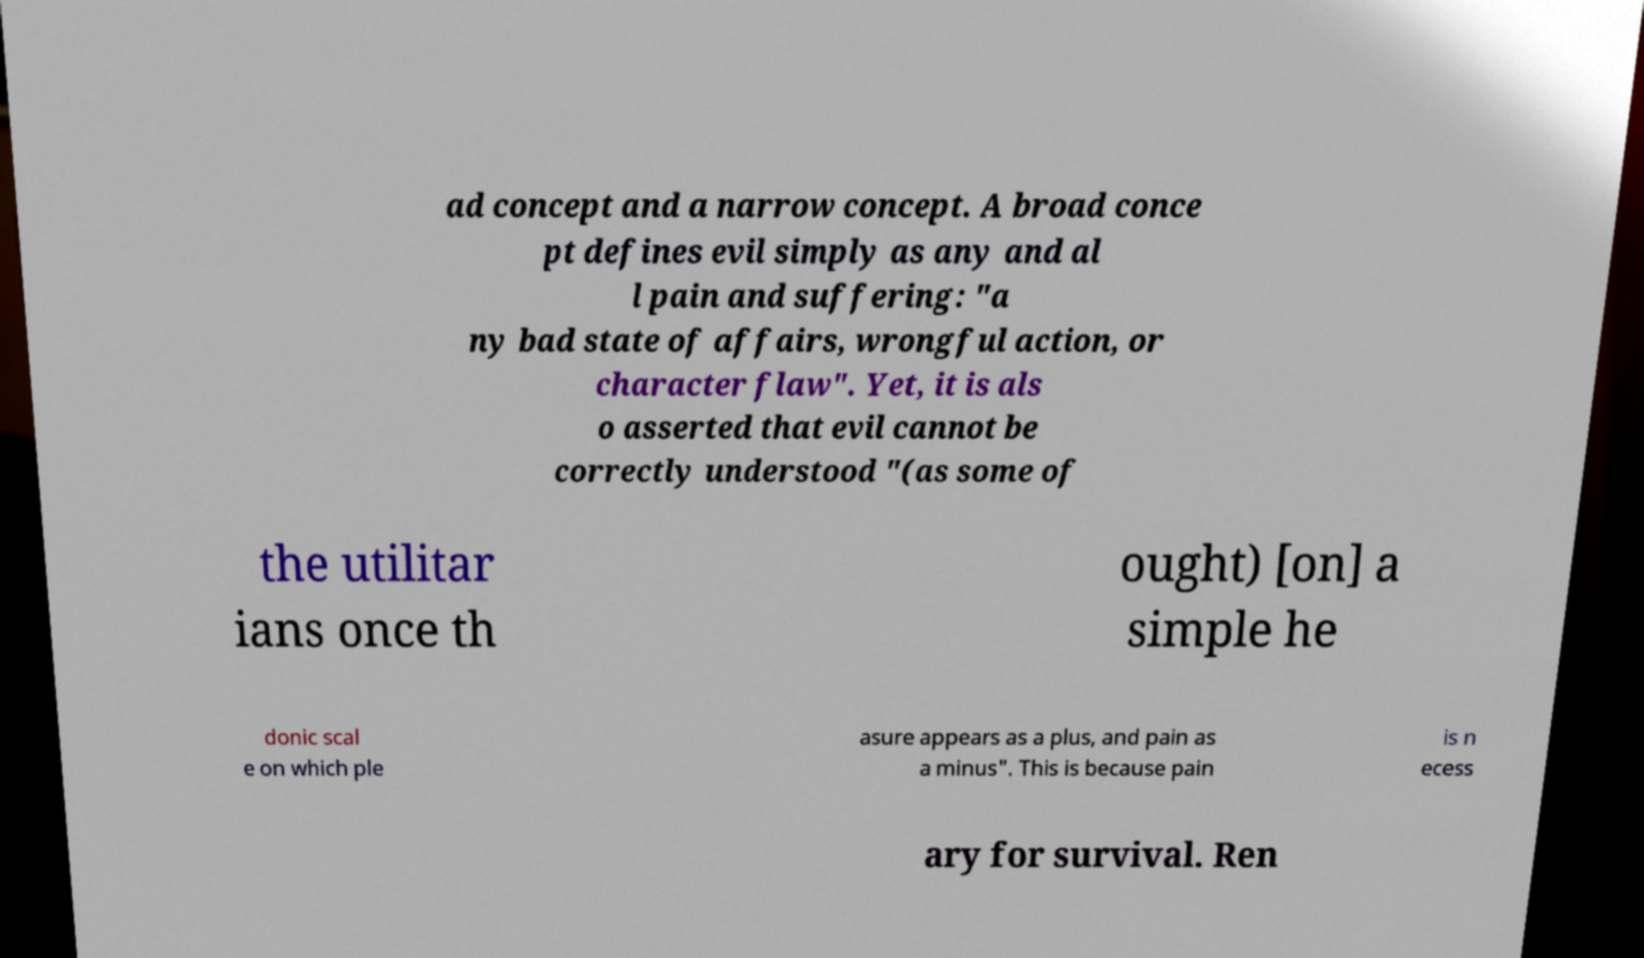Please read and relay the text visible in this image. What does it say? ad concept and a narrow concept. A broad conce pt defines evil simply as any and al l pain and suffering: "a ny bad state of affairs, wrongful action, or character flaw". Yet, it is als o asserted that evil cannot be correctly understood "(as some of the utilitar ians once th ought) [on] a simple he donic scal e on which ple asure appears as a plus, and pain as a minus". This is because pain is n ecess ary for survival. Ren 